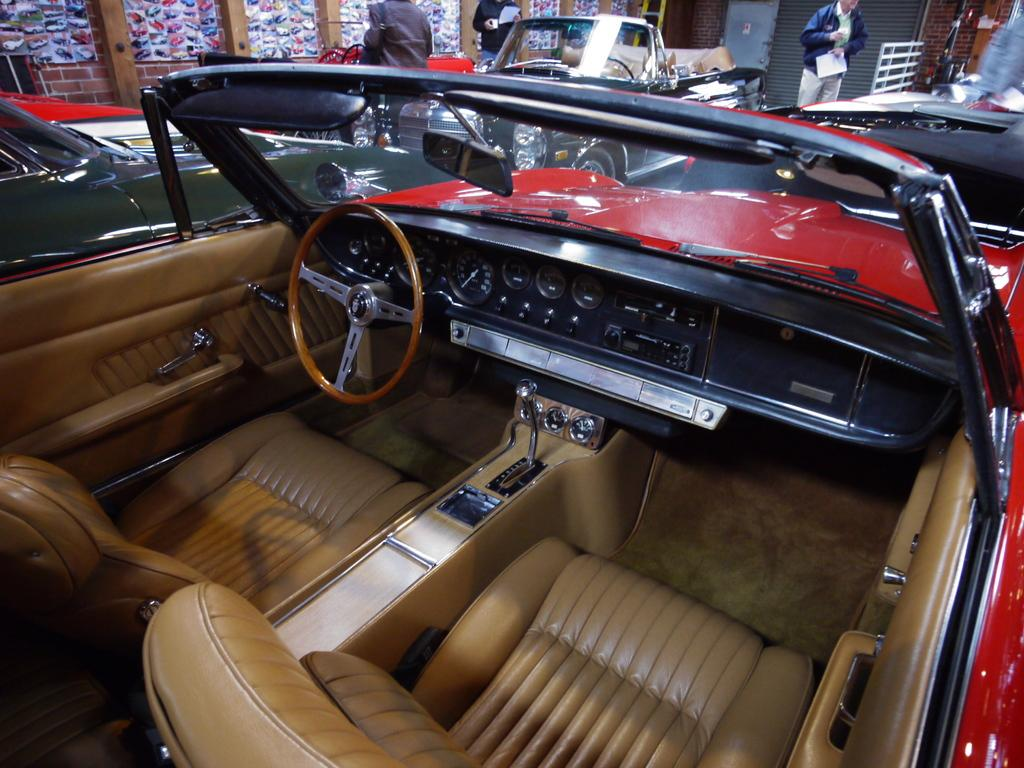What is located in the middle of the image? There are vehicles in the middle of the image. What are the people behind the vehicles doing? The people are standing behind the vehicles and holding papers. What can be seen in the background of the image? There is a wall visible in the background of the image. Can you tell me how many curves are present in the river shown in the image? There is no river present in the image; it features vehicles and people holding papers. What type of nose can be seen on the person standing behind the vehicles? There is no person's nose visible in the image; it only shows vehicles and people holding papers. 